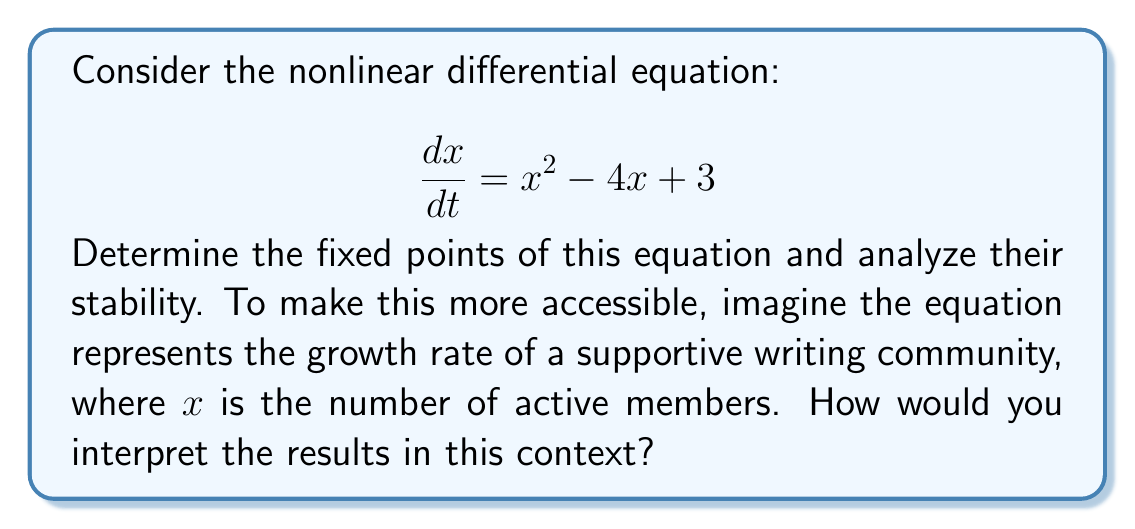Provide a solution to this math problem. Let's approach this step-by-step:

1) First, we need to find the fixed points. Fixed points occur when $\frac{dx}{dt} = 0$. So, we set the equation equal to zero:

   $$x^2 - 4x + 3 = 0$$

2) This is a quadratic equation. We can solve it using the quadratic formula:
   $x = \frac{-b \pm \sqrt{b^2 - 4ac}}{2a}$, where $a=1$, $b=-4$, and $c=3$

   $$x = \frac{4 \pm \sqrt{16 - 12}}{2} = \frac{4 \pm \sqrt{4}}{2} = \frac{4 \pm 2}{2}$$

3) This gives us two fixed points:
   $x_1 = \frac{4 + 2}{2} = 3$ and $x_2 = \frac{4 - 2}{2} = 1$

4) To determine stability, we need to look at the derivative of the right-hand side of the original equation:

   $$\frac{d}{dx}(x^2 - 4x + 3) = 2x - 4$$

5) We evaluate this at each fixed point:
   At $x_1 = 3$: $2(3) - 4 = 2 > 0$ (unstable)
   At $x_2 = 1$: $2(1) - 4 = -2 < 0$ (stable)

6) Interpretation for the writing community:
   - The fixed point at $x = 1$ represents a stable equilibrium of 1 active member. If the community size is close to this, it will tend towards it.
   - The fixed point at $x = 3$ represents an unstable equilibrium of 3 active members. If the community size is slightly above this, it will grow, and if it's slightly below, it will shrink.
   - This suggests that the community needs to reach a critical mass (more than 3 members) to sustainably grow.
Answer: Fixed points: $x_1 = 3$ (unstable), $x_2 = 1$ (stable) 